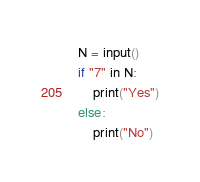<code> <loc_0><loc_0><loc_500><loc_500><_C_>N = input()
if "7" in N:
    print("Yes")
else:
    print("No")</code> 